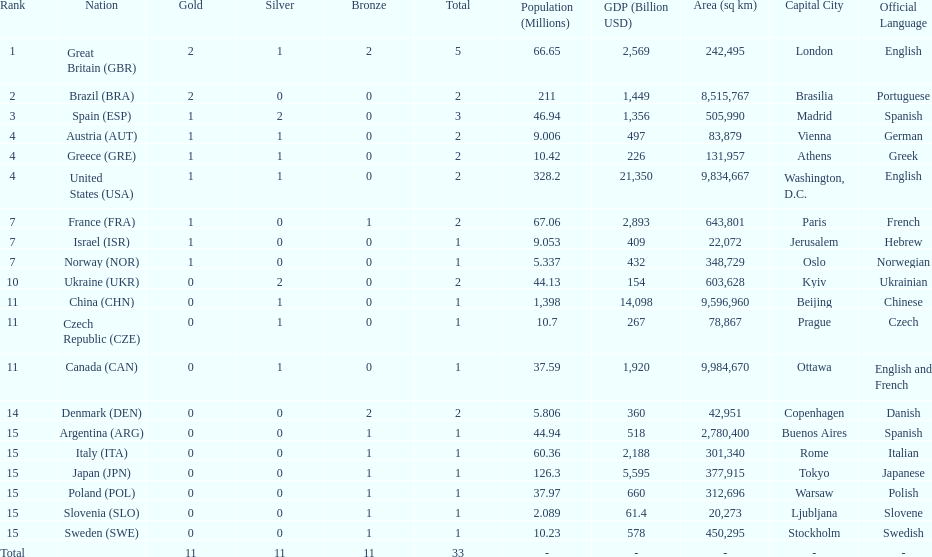Can you give me this table as a dict? {'header': ['Rank', 'Nation', 'Gold', 'Silver', 'Bronze', 'Total', 'Population (Millions)', 'GDP (Billion USD)', 'Area (sq km)', 'Capital City', 'Official Language'], 'rows': [['1', 'Great Britain\xa0(GBR)', '2', '1', '2', '5', '66.65', '2,569', '242,495', 'London', 'English'], ['2', 'Brazil\xa0(BRA)', '2', '0', '0', '2', '211', '1,449', '8,515,767', 'Brasilia', 'Portuguese'], ['3', 'Spain\xa0(ESP)', '1', '2', '0', '3', '46.94', '1,356', '505,990', 'Madrid', 'Spanish'], ['4', 'Austria\xa0(AUT)', '1', '1', '0', '2', '9.006', '497', '83,879', 'Vienna', 'German'], ['4', 'Greece\xa0(GRE)', '1', '1', '0', '2', '10.42', '226', '131,957', 'Athens', 'Greek'], ['4', 'United States\xa0(USA)', '1', '1', '0', '2', '328.2', '21,350', '9,834,667', 'Washington, D.C.', 'English'], ['7', 'France\xa0(FRA)', '1', '0', '1', '2', '67.06', '2,893', '643,801', 'Paris', 'French'], ['7', 'Israel\xa0(ISR)', '1', '0', '0', '1', '9.053', '409', '22,072', 'Jerusalem', 'Hebrew'], ['7', 'Norway\xa0(NOR)', '1', '0', '0', '1', '5.337', '432', '348,729', 'Oslo', 'Norwegian'], ['10', 'Ukraine\xa0(UKR)', '0', '2', '0', '2', '44.13', '154', '603,628', 'Kyiv', 'Ukrainian'], ['11', 'China\xa0(CHN)', '0', '1', '0', '1', '1,398', '14,098', '9,596,960', 'Beijing', 'Chinese'], ['11', 'Czech Republic\xa0(CZE)', '0', '1', '0', '1', '10.7', '267', '78,867', 'Prague', 'Czech'], ['11', 'Canada\xa0(CAN)', '0', '1', '0', '1', '37.59', '1,920', '9,984,670', 'Ottawa', 'English and French'], ['14', 'Denmark\xa0(DEN)', '0', '0', '2', '2', '5.806', '360', '42,951', 'Copenhagen', 'Danish'], ['15', 'Argentina\xa0(ARG)', '0', '0', '1', '1', '44.94', '518', '2,780,400', 'Buenos Aires', 'Spanish'], ['15', 'Italy\xa0(ITA)', '0', '0', '1', '1', '60.36', '2,188', '301,340', 'Rome', 'Italian'], ['15', 'Japan\xa0(JPN)', '0', '0', '1', '1', '126.3', '5,595', '377,915', 'Tokyo', 'Japanese'], ['15', 'Poland\xa0(POL)', '0', '0', '1', '1', '37.97', '660', '312,696', 'Warsaw', 'Polish'], ['15', 'Slovenia\xa0(SLO)', '0', '0', '1', '1', '2.089', '61.4', '20,273', 'Ljubljana', 'Slovene'], ['15', 'Sweden\xa0(SWE)', '0', '0', '1', '1', '10.23', '578', '450,295', 'Stockholm', 'Swedish'], ['Total', '', '11', '11', '11', '33', '-', '-', '-', '-', '-']]} What country had the most medals? Great Britain. 